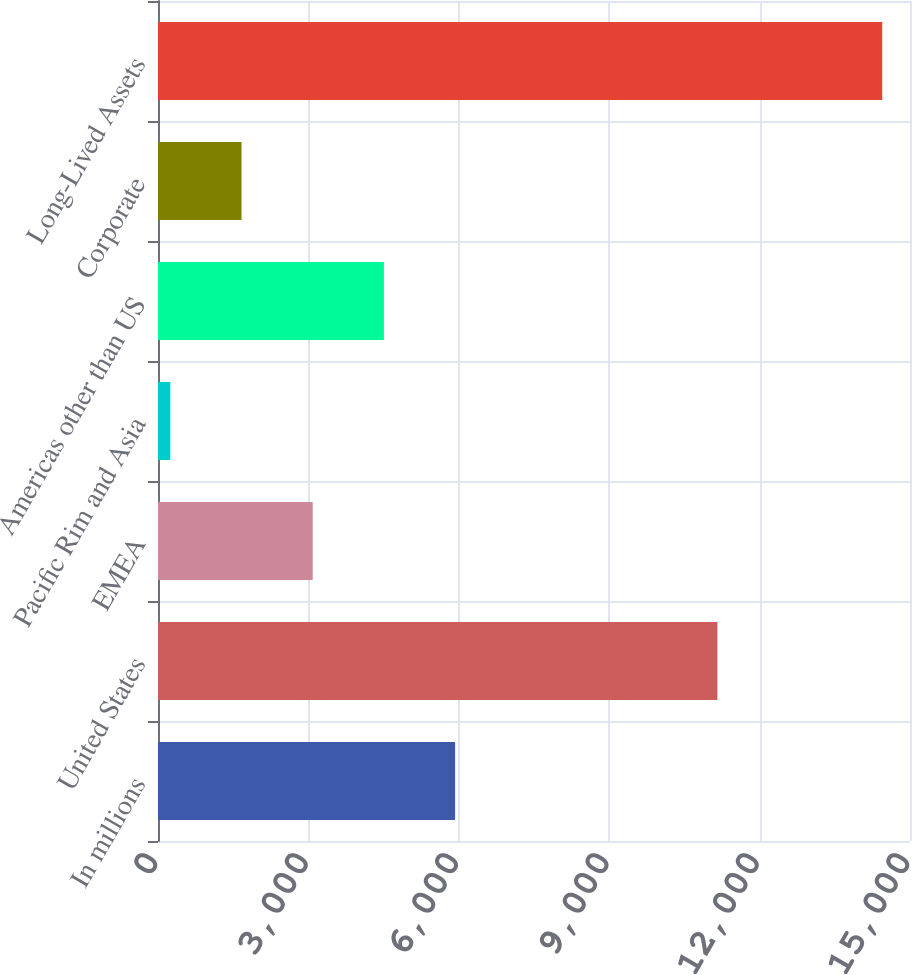Convert chart. <chart><loc_0><loc_0><loc_500><loc_500><bar_chart><fcel>In millions<fcel>United States<fcel>EMEA<fcel>Pacific Rim and Asia<fcel>Americas other than US<fcel>Corporate<fcel>Long-Lived Assets<nl><fcel>5926<fcel>11158<fcel>3086<fcel>246<fcel>4506<fcel>1666<fcel>14446<nl></chart> 